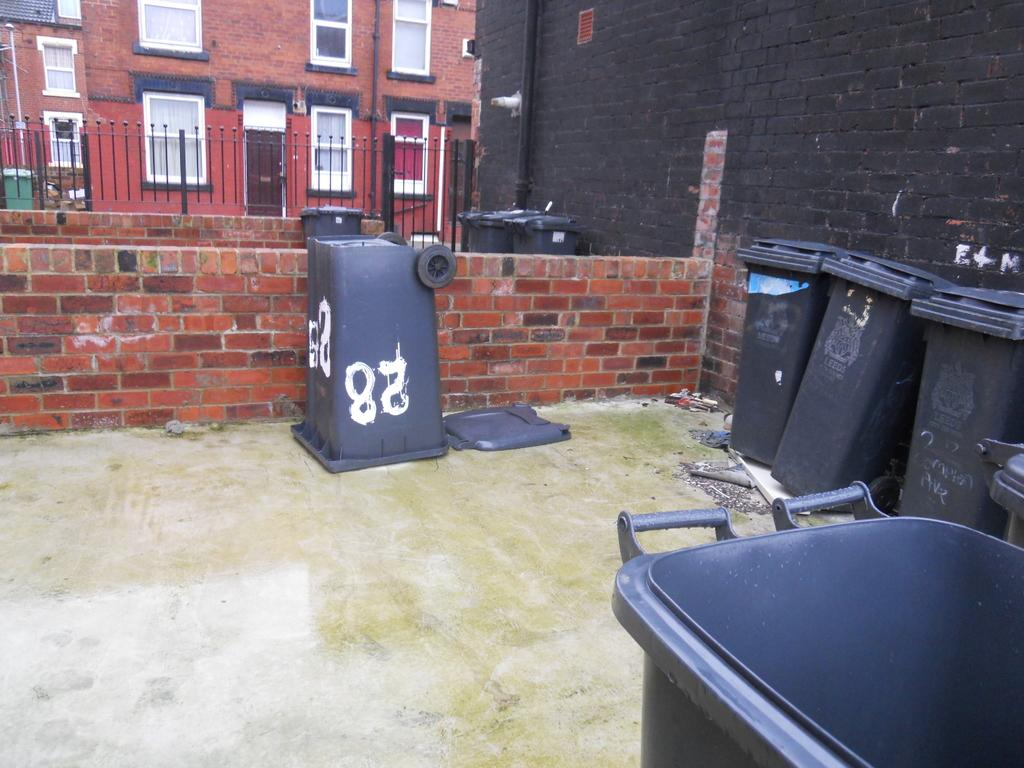<image>
Share a concise interpretation of the image provided. A group of trash cans are stored in a residential area, with Leeds on them and one with a #28. 